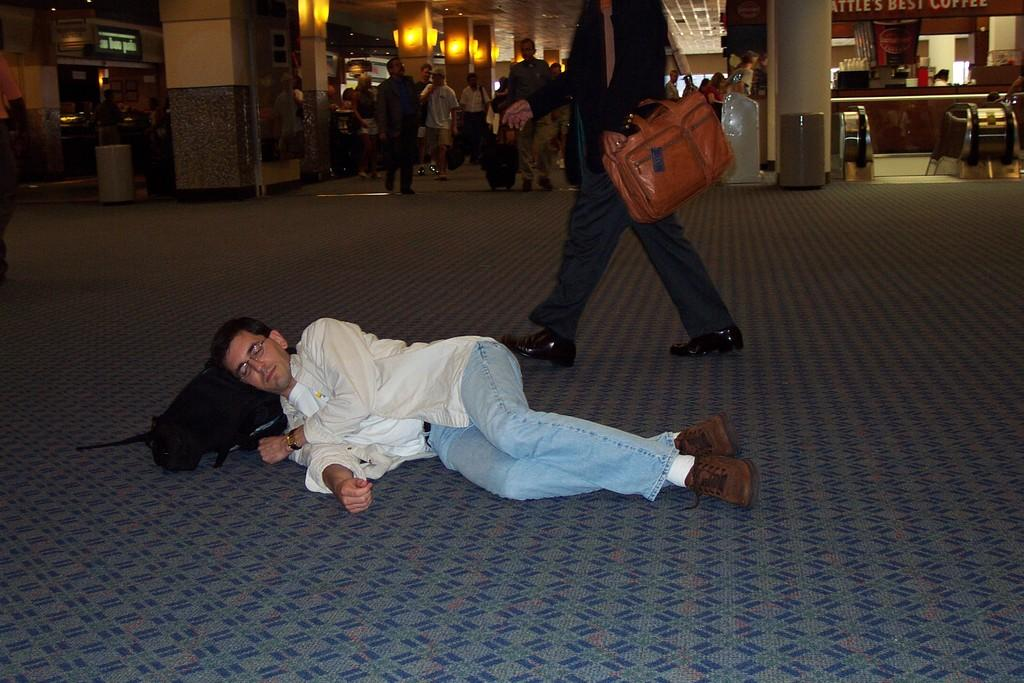What are the persons in the image doing? The persons in the image are on the floor. Can you describe the position of one of the persons? One person is lying on a bag. What can be seen in the background of the image? There are pillars, name boards, bins, and stalls visible in the background of the image. What type of knowledge can be seen being shared between the persons in the image? There is no indication of knowledge sharing in the image; it only shows persons on the floor and various elements in the background. 